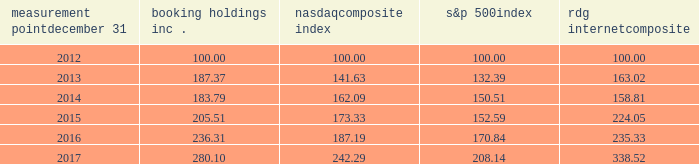Measurement point december 31 booking holdings nasdaq composite index s&p 500 rdg internet composite .
Sales of unregistered securities between october 1 , 2017 and december 31 , 2017 , we issued 103343 shares of our common stock in connection with the conversion of $ 196.1 million principal amount of our 1.0% ( 1.0 % ) convertible senior notes due 2018 .
The conversions were effected in accordance with the indenture , which provides that the principal amount of converted notes be paid in cash and the conversion premium be paid in cash and/or shares of common stock at our election .
In each case , we chose to pay the conversion premium in shares of common stock ( fractional shares are paid in cash ) .
The issuances of the shares were not registered under the securities act of 1933 , as amended ( the "act" ) pursuant to section 3 ( a ) ( 9 ) of the act. .
What was the percentage difference between booking holdings inc . and the s&p 500 index for the five years ended 2017? 
Computations: (((280.10 - 100) / 100) - ((208.14 - 100) / 100))
Answer: 0.7196. 